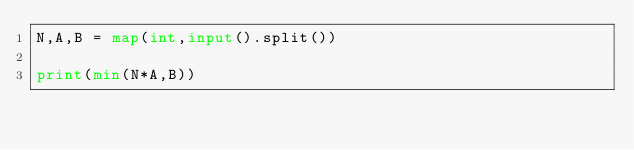<code> <loc_0><loc_0><loc_500><loc_500><_Python_>N,A,B = map(int,input().split())

print(min(N*A,B))
</code> 